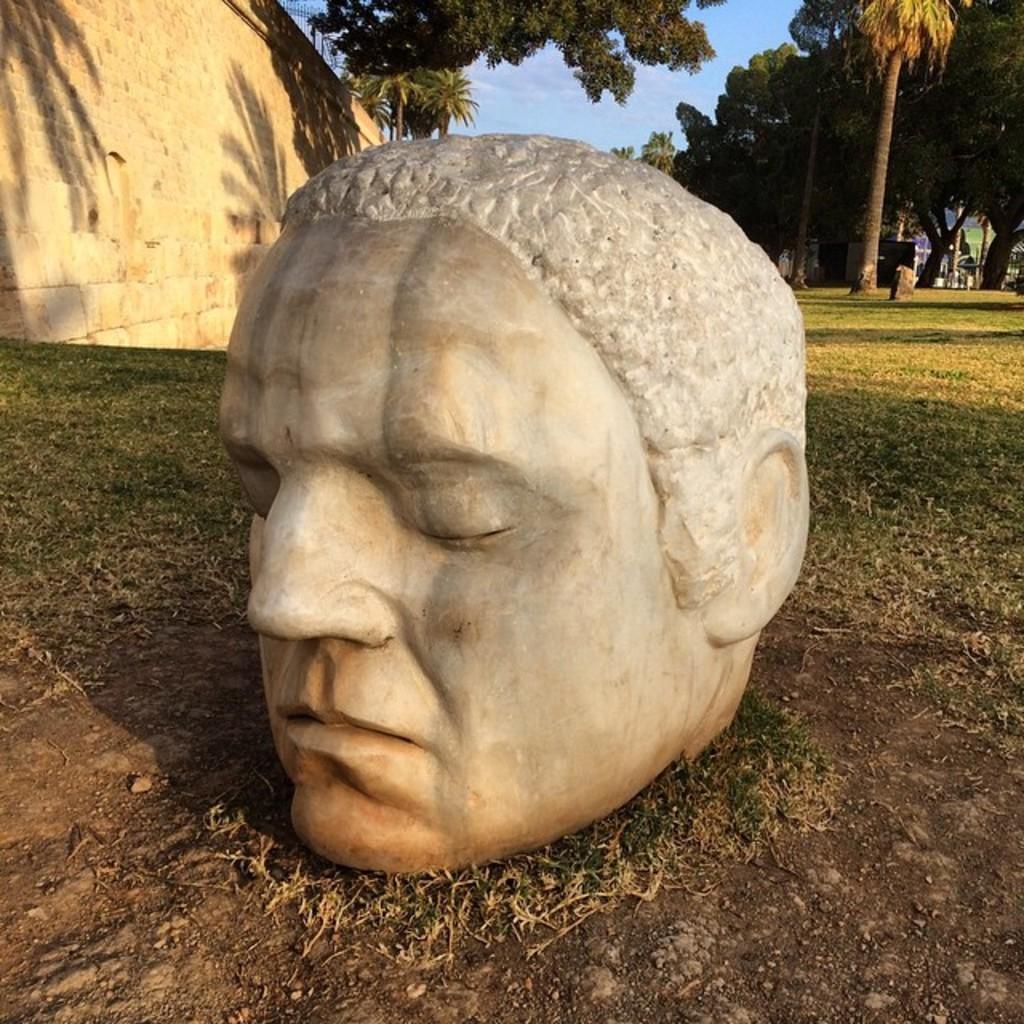Please provide a concise description of this image. In the center of the image there is a depiction of a person on the ground. In the background of the image there are trees. To the left side of the image there is wall. 